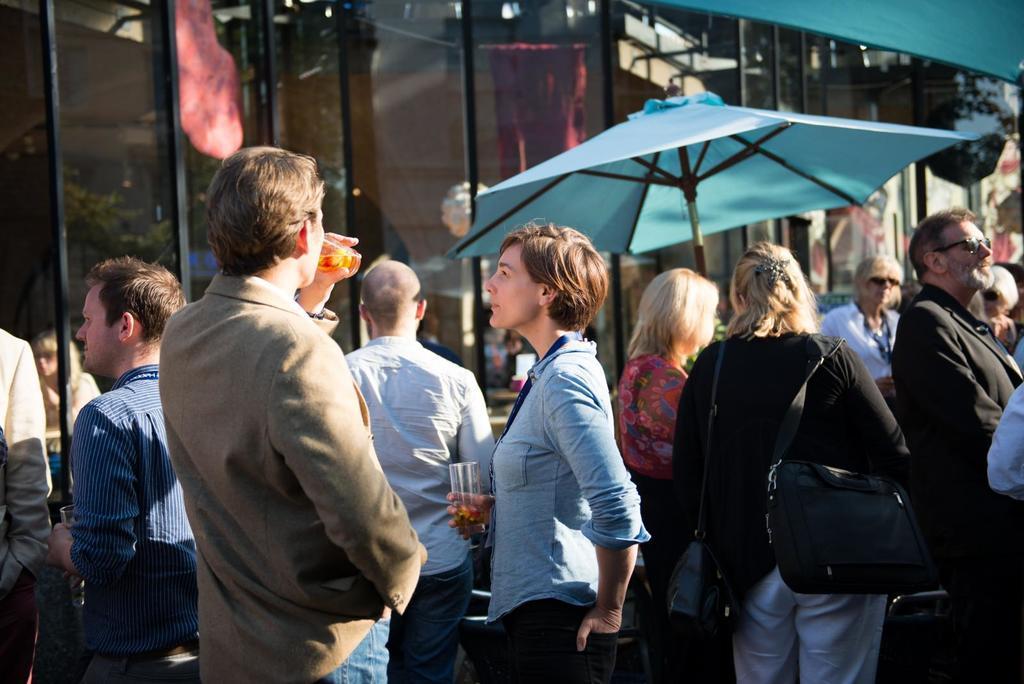In one or two sentences, can you explain what this image depicts? In the image we can see there are many people standing, wearing clothes. This is a glass, identity card, handbag, umbrella, hair clip, goggles. There is a building made up of glass. 